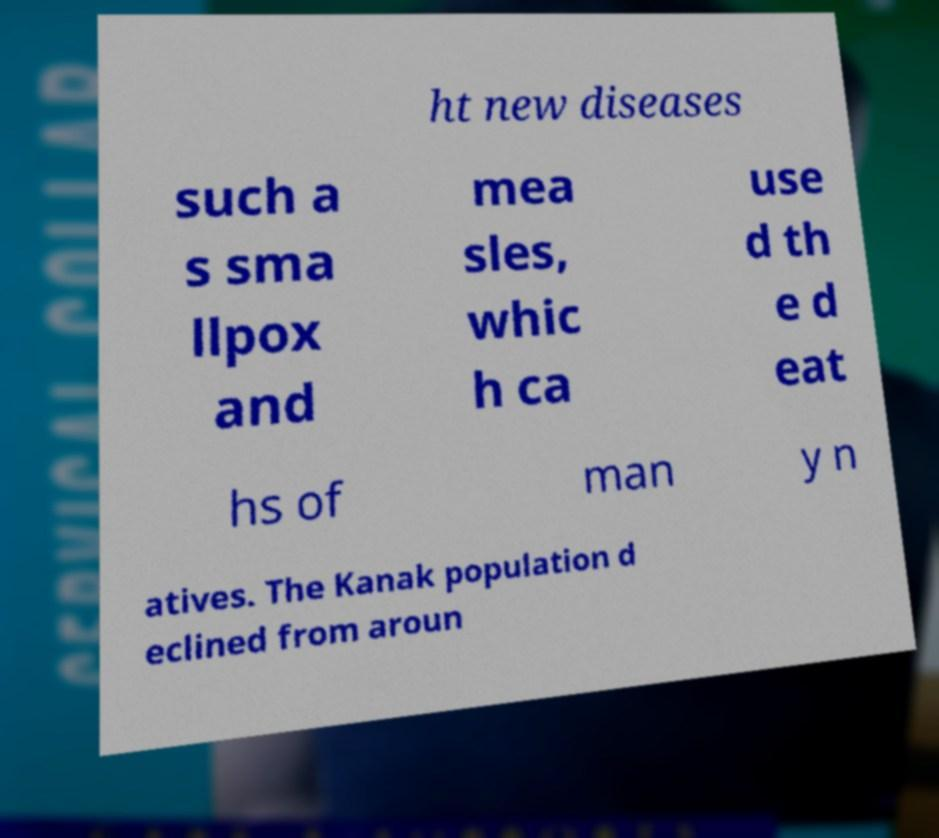What messages or text are displayed in this image? I need them in a readable, typed format. ht new diseases such a s sma llpox and mea sles, whic h ca use d th e d eat hs of man y n atives. The Kanak population d eclined from aroun 